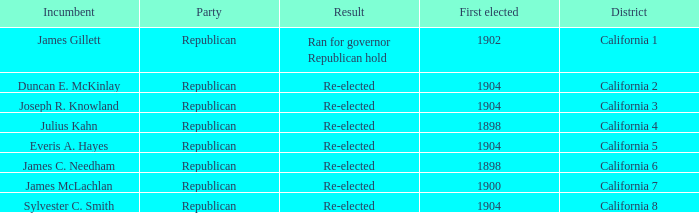Which Incumbent has a District of California 5? Everis A. Hayes. 